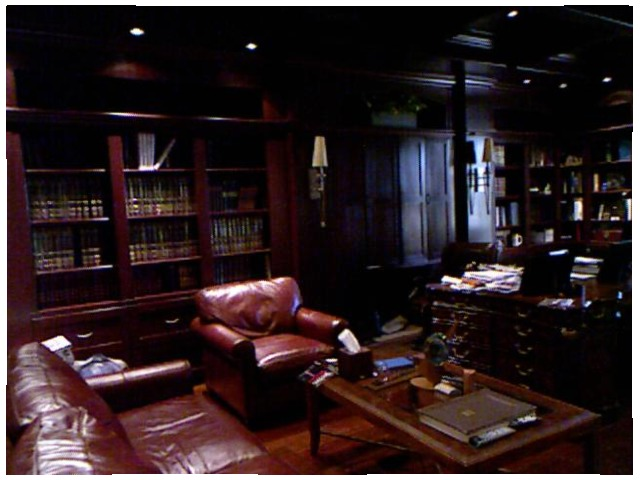<image>
Is there a book on the shelf? Yes. Looking at the image, I can see the book is positioned on top of the shelf, with the shelf providing support. Where is the chair in relation to the book? Is it behind the book? Yes. From this viewpoint, the chair is positioned behind the book, with the book partially or fully occluding the chair. 